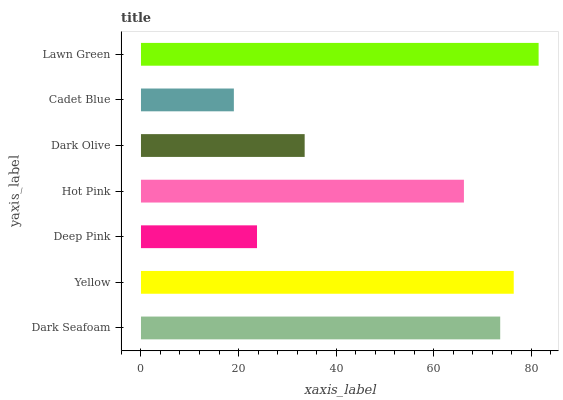Is Cadet Blue the minimum?
Answer yes or no. Yes. Is Lawn Green the maximum?
Answer yes or no. Yes. Is Yellow the minimum?
Answer yes or no. No. Is Yellow the maximum?
Answer yes or no. No. Is Yellow greater than Dark Seafoam?
Answer yes or no. Yes. Is Dark Seafoam less than Yellow?
Answer yes or no. Yes. Is Dark Seafoam greater than Yellow?
Answer yes or no. No. Is Yellow less than Dark Seafoam?
Answer yes or no. No. Is Hot Pink the high median?
Answer yes or no. Yes. Is Hot Pink the low median?
Answer yes or no. Yes. Is Cadet Blue the high median?
Answer yes or no. No. Is Dark Olive the low median?
Answer yes or no. No. 